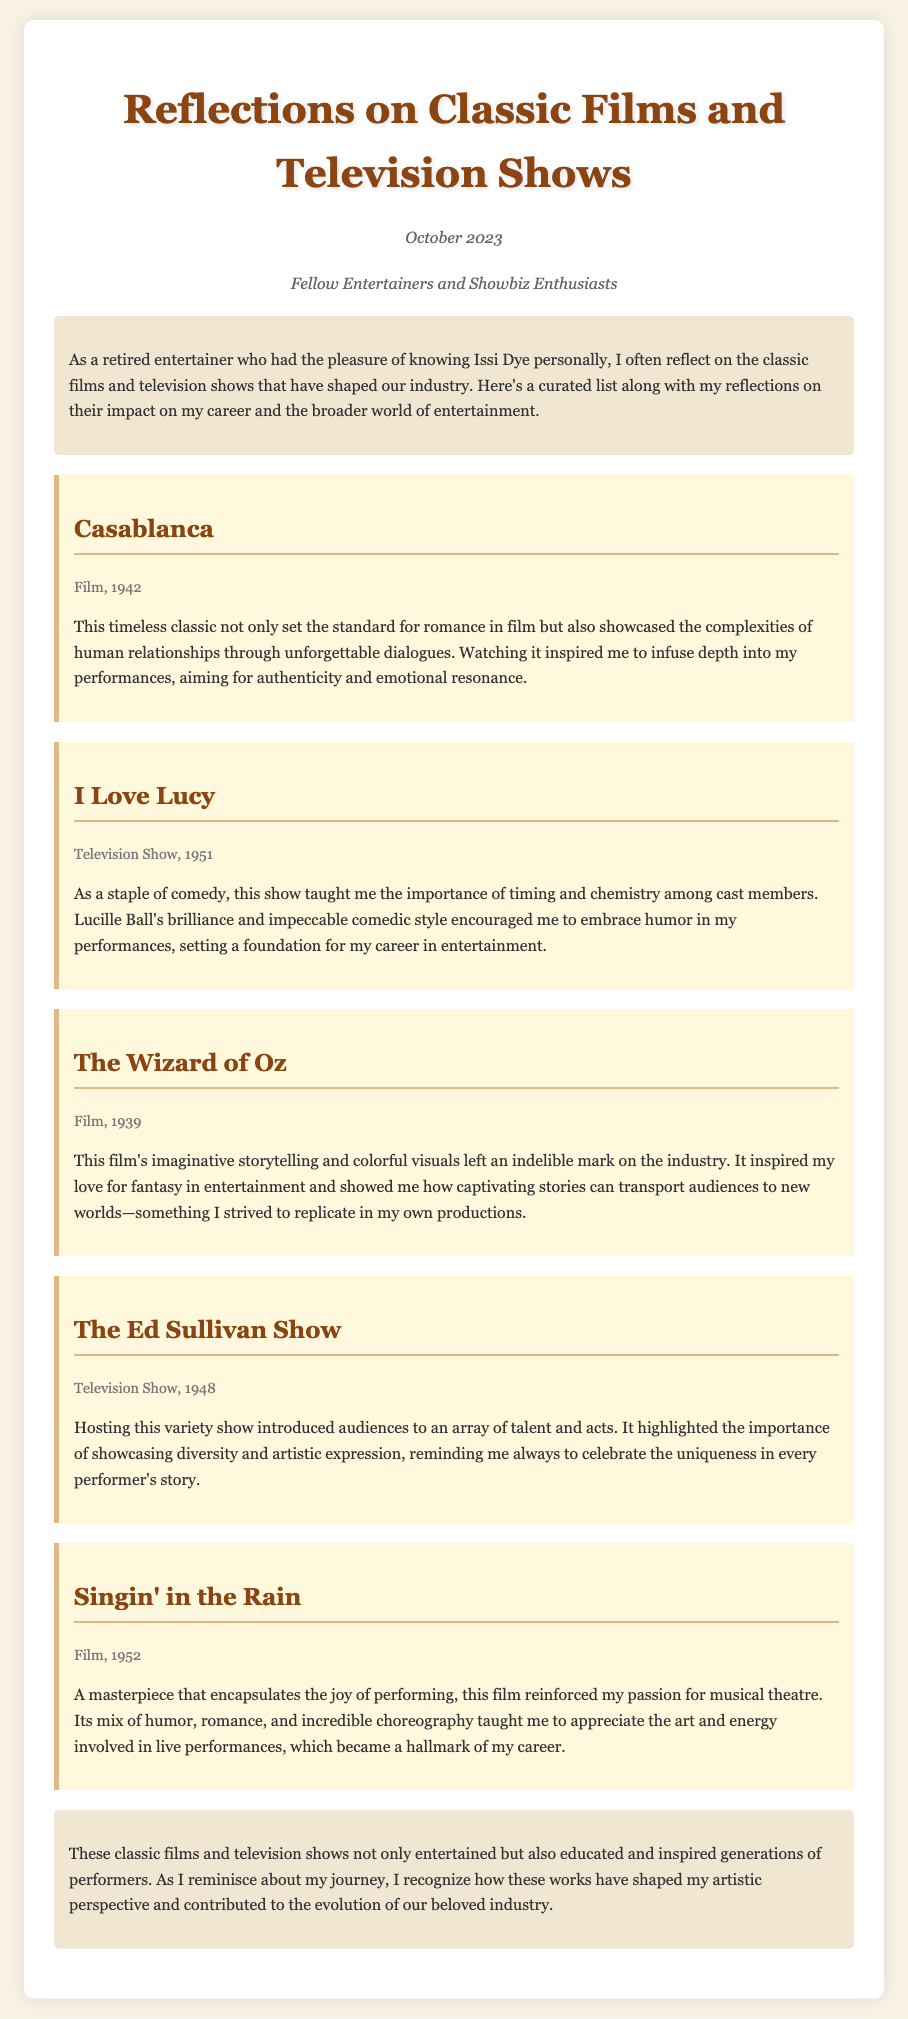What is the title of the memo? The title of the memo is mentioned at the top of the document, clearly indicating its subject.
Answer: Reflections on Classic Films and Television Shows Who was the memo addressed to? The memo specifies its audience in the section designed for that purpose.
Answer: Fellow Entertainers and Showbiz Enthusiasts What year was "Casablanca" released? The release year is provided under the title of the film within its recommendation section.
Answer: 1942 What does "I Love Lucy" emphasize in performances? The memo explains the significance of timing and chemistry as stated in the reflection about the show.
Answer: Timing and chemistry Which film inspired the writer's love for fantasy in entertainment? The document highlights this film in the recommendation along with its impact on the writer.
Answer: The Wizard of Oz What was the primary focus of "The Ed Sullivan Show"? This show is discussed in terms of its impact on diversity and artistic expression among performers.
Answer: Showcasing diversity and artistic expression Which film is described as encapsulating the joy of performing? The memo clearly describes this characteristic in the reflection about the film.
Answer: Singin' in the Rain What is the overall impact of the classic films and television shows discussed? The conclusion provides a summary of their influence on performers and the industry.
Answer: Educated and inspired generations of performers 